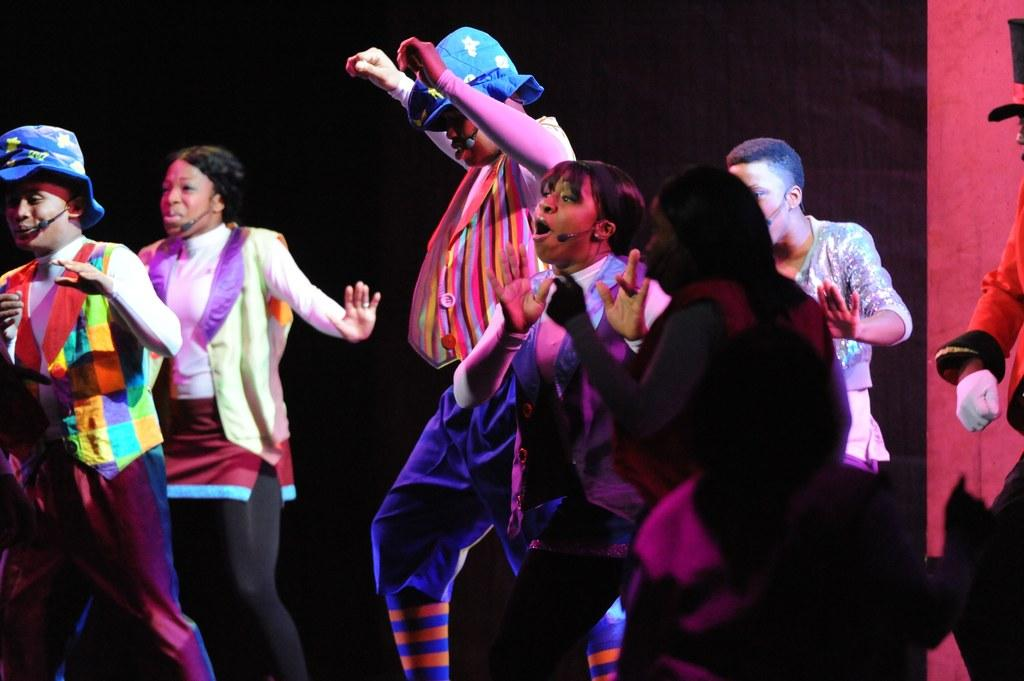What are the people in the image doing? The people in the image are dancing and singing. Can you describe the background of the image? The background of the image is dark. How many grapes are being eaten by the mice in the image? There are no mice or grapes present in the image. 